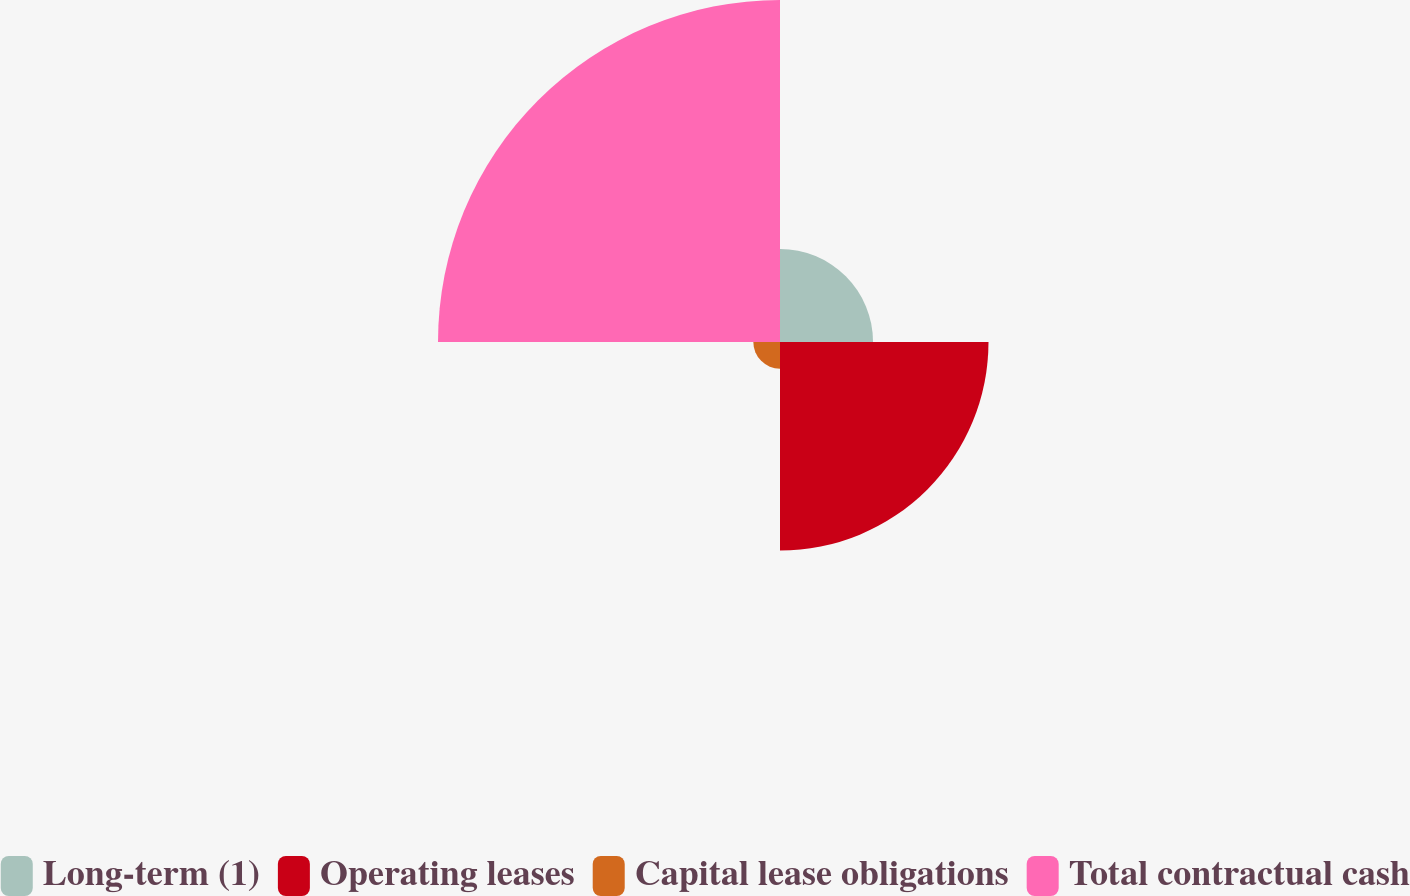Convert chart. <chart><loc_0><loc_0><loc_500><loc_500><pie_chart><fcel>Long-term (1)<fcel>Operating leases<fcel>Capital lease obligations<fcel>Total contractual cash<nl><fcel>13.88%<fcel>31.11%<fcel>3.98%<fcel>51.03%<nl></chart> 